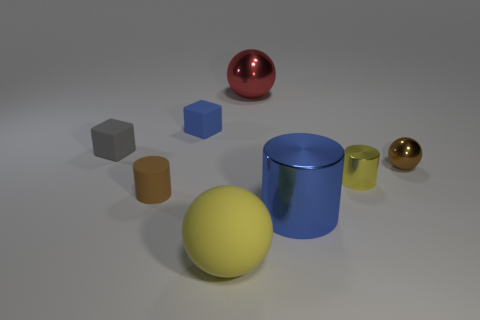What number of other things are there of the same shape as the big yellow object?
Make the answer very short. 2. Does the blue object left of the big cylinder have the same shape as the blue thing in front of the gray matte block?
Ensure brevity in your answer.  No. What number of blocks are red metal things or gray matte things?
Ensure brevity in your answer.  1. The large sphere in front of the big metallic object in front of the small cylinder to the left of the blue metal cylinder is made of what material?
Provide a succinct answer. Rubber. How many other objects are the same size as the yellow rubber thing?
Offer a terse response. 2. What is the size of the cylinder that is the same color as the rubber sphere?
Offer a very short reply. Small. Is the number of blue objects that are in front of the blue metallic object greater than the number of brown things?
Your response must be concise. No. Are there any big cylinders that have the same color as the small rubber cylinder?
Your answer should be very brief. No. What color is the other metal thing that is the same size as the brown metal object?
Provide a short and direct response. Yellow. How many big things are behind the tiny cylinder that is left of the tiny blue matte object?
Give a very brief answer. 1. 